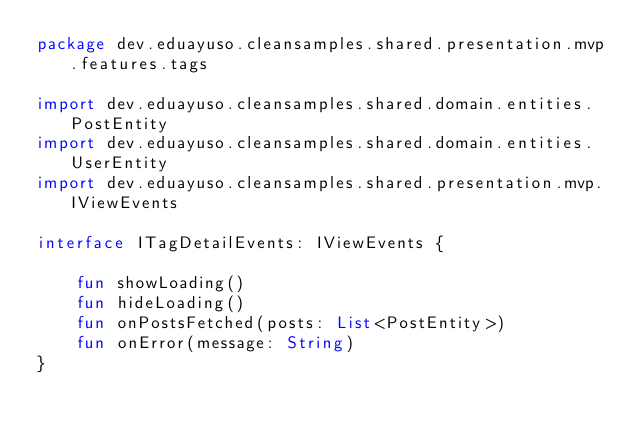Convert code to text. <code><loc_0><loc_0><loc_500><loc_500><_Kotlin_>package dev.eduayuso.cleansamples.shared.presentation.mvp.features.tags

import dev.eduayuso.cleansamples.shared.domain.entities.PostEntity
import dev.eduayuso.cleansamples.shared.domain.entities.UserEntity
import dev.eduayuso.cleansamples.shared.presentation.mvp.IViewEvents

interface ITagDetailEvents: IViewEvents {

    fun showLoading()
    fun hideLoading()
    fun onPostsFetched(posts: List<PostEntity>)
    fun onError(message: String)
}</code> 